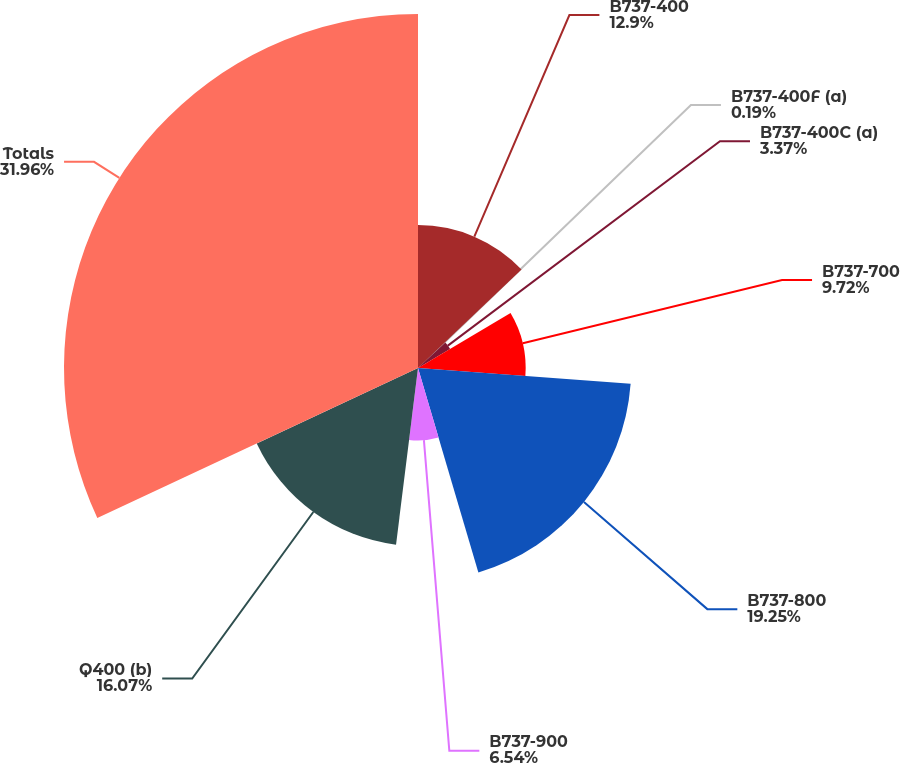<chart> <loc_0><loc_0><loc_500><loc_500><pie_chart><fcel>B737-400<fcel>B737-400F (a)<fcel>B737-400C (a)<fcel>B737-700<fcel>B737-800<fcel>B737-900<fcel>Q400 (b)<fcel>Totals<nl><fcel>12.9%<fcel>0.19%<fcel>3.37%<fcel>9.72%<fcel>19.25%<fcel>6.54%<fcel>16.07%<fcel>31.96%<nl></chart> 